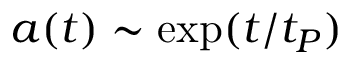Convert formula to latex. <formula><loc_0><loc_0><loc_500><loc_500>a ( t ) \sim \exp ( t / t _ { P } )</formula> 